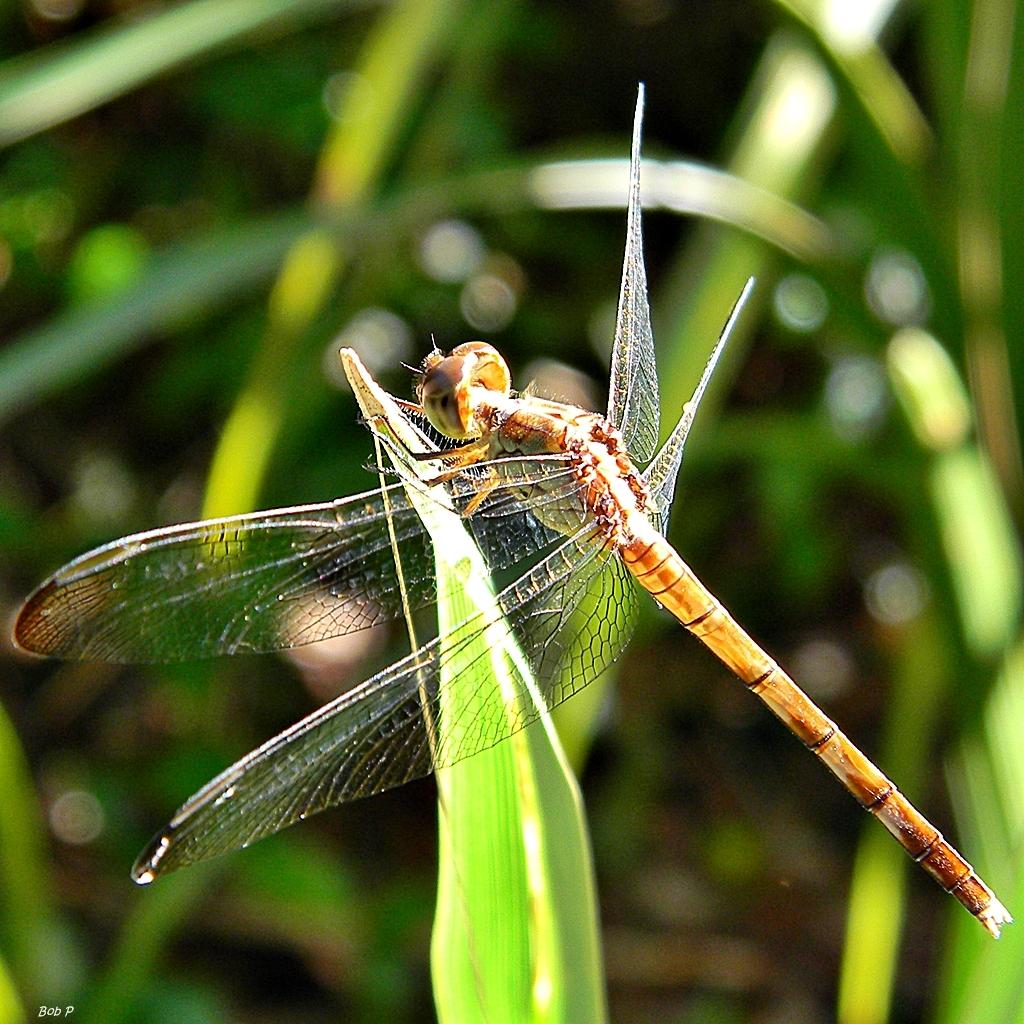What is on the leaf in the image? There is a fly on a leaf in the image. What can be seen in the background of the image? There are plants in the background of the image. What type of yarn is the chicken using to knit a sweater in the image? There is no chicken or yarn present in the image; it features a fly on a leaf and plants in the background. 